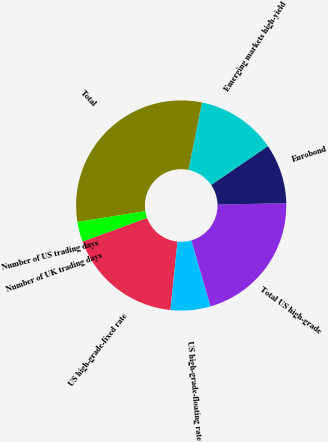<chart> <loc_0><loc_0><loc_500><loc_500><pie_chart><fcel>US high-grade-fixed rate<fcel>US high-grade-floating rate<fcel>Total US high-grade<fcel>Eurobond<fcel>Emerging markets high-yield<fcel>Total<fcel>Number of US trading days<fcel>Number of UK trading days<nl><fcel>17.78%<fcel>6.14%<fcel>20.84%<fcel>9.21%<fcel>12.27%<fcel>30.66%<fcel>3.08%<fcel>0.01%<nl></chart> 